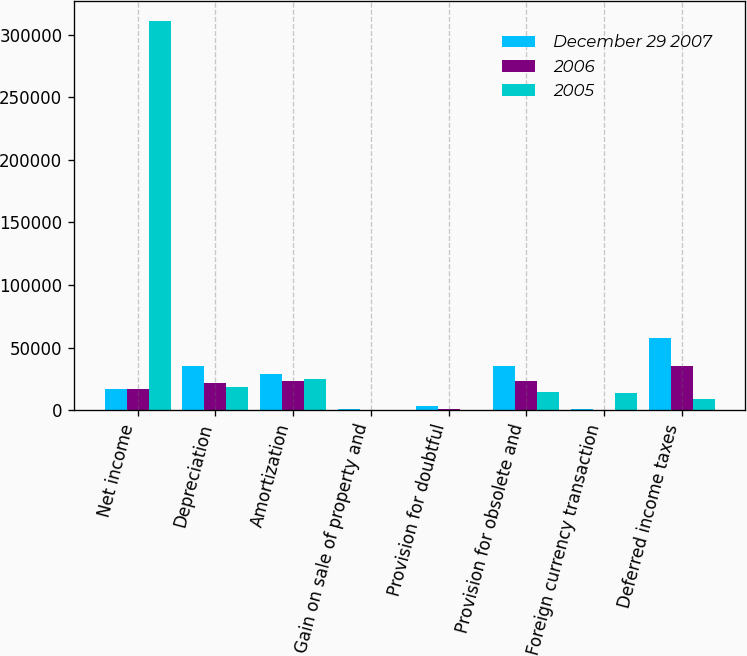Convert chart. <chart><loc_0><loc_0><loc_500><loc_500><stacked_bar_chart><ecel><fcel>Net income<fcel>Depreciation<fcel>Amortization<fcel>Gain on sale of property and<fcel>Provision for doubtful<fcel>Provision for obsolete and<fcel>Foreign currency transaction<fcel>Deferred income taxes<nl><fcel>December 29 2007<fcel>16724<fcel>35524<fcel>28513<fcel>560<fcel>3617<fcel>34975<fcel>926<fcel>57843<nl><fcel>2006<fcel>16724<fcel>21535<fcel>22940<fcel>67<fcel>955<fcel>23245<fcel>344<fcel>35060<nl><fcel>2005<fcel>311219<fcel>18693<fcel>24903<fcel>37<fcel>445<fcel>14755<fcel>13957<fcel>8833<nl></chart> 